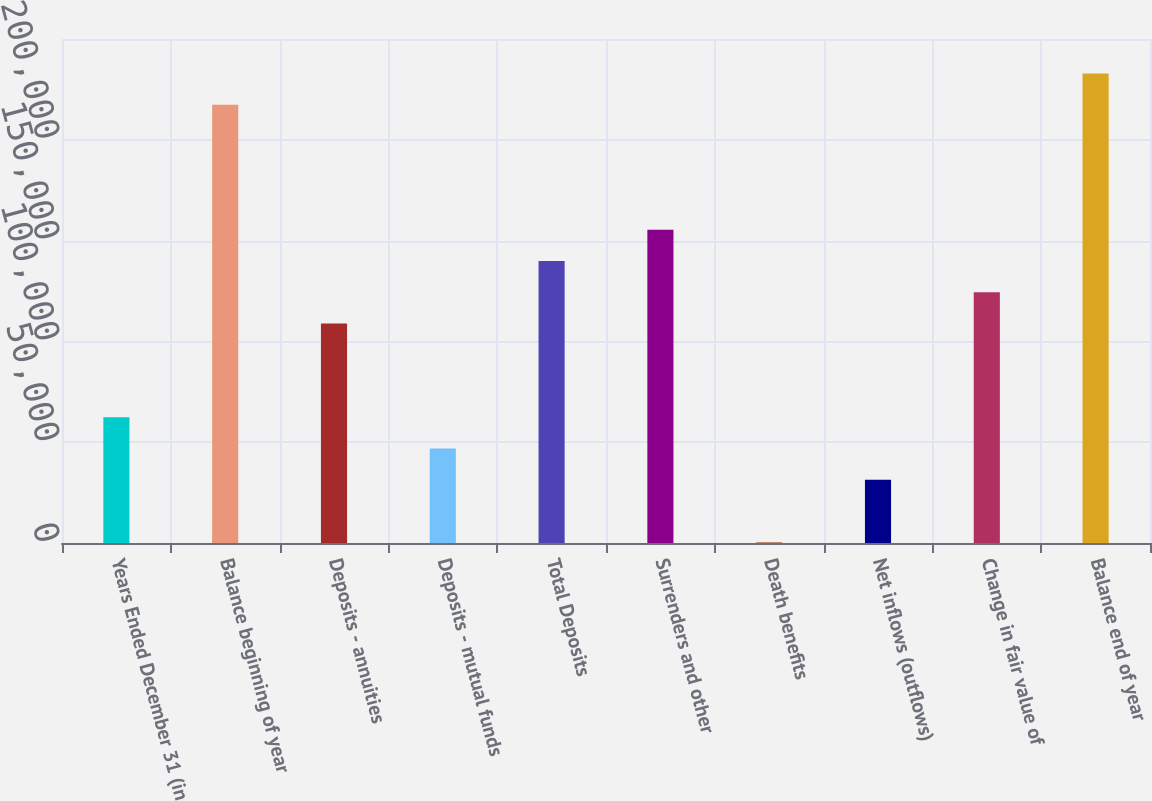<chart> <loc_0><loc_0><loc_500><loc_500><bar_chart><fcel>Years Ended December 31 (in<fcel>Balance beginning of year<fcel>Deposits - annuities<fcel>Deposits - mutual funds<fcel>Total Deposits<fcel>Surrenders and other<fcel>Death benefits<fcel>Net inflows (outflows)<fcel>Change in fair value of<fcel>Balance end of year<nl><fcel>62330.6<fcel>217365<fcel>108841<fcel>46827.2<fcel>139848<fcel>155351<fcel>317<fcel>31323.8<fcel>124344<fcel>232868<nl></chart> 